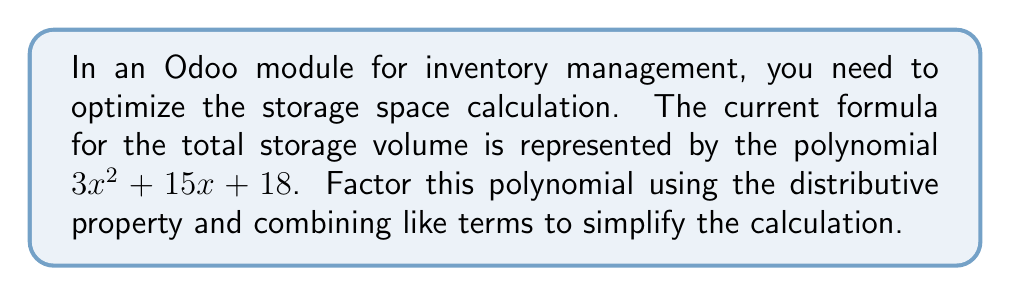Solve this math problem. Let's approach this step-by-step:

1) First, we need to identify if there's a common factor for all terms:
   $3x^2 + 15x + 18$
   
   We can see that 3 is a common factor:
   $3(x^2 + 5x + 6)$

2) Now, we focus on factoring the expression inside the parentheses: $x^2 + 5x + 6$

3) We're looking for two numbers that multiply to give 6 and add up to 5. These numbers are 2 and 3.

4) We can rewrite the middle term using these numbers:
   $x^2 + 2x + 3x + 6$

5) Now we can group the terms:
   $(x^2 + 2x) + (3x + 6)$

6) Factor out the common factor from each group:
   $x(x + 2) + 3(x + 2)$

7) We can now see that $(x + 2)$ is common to both terms:
   $(x + 3)(x + 2)$

8) Remember, we factored out 3 at the beginning. So our final factored form is:
   $3(x + 3)(x + 2)$

This factored form represents the same polynomial but in a more computationally efficient format for the Odoo module.
Answer: $3(x + 3)(x + 2)$ 